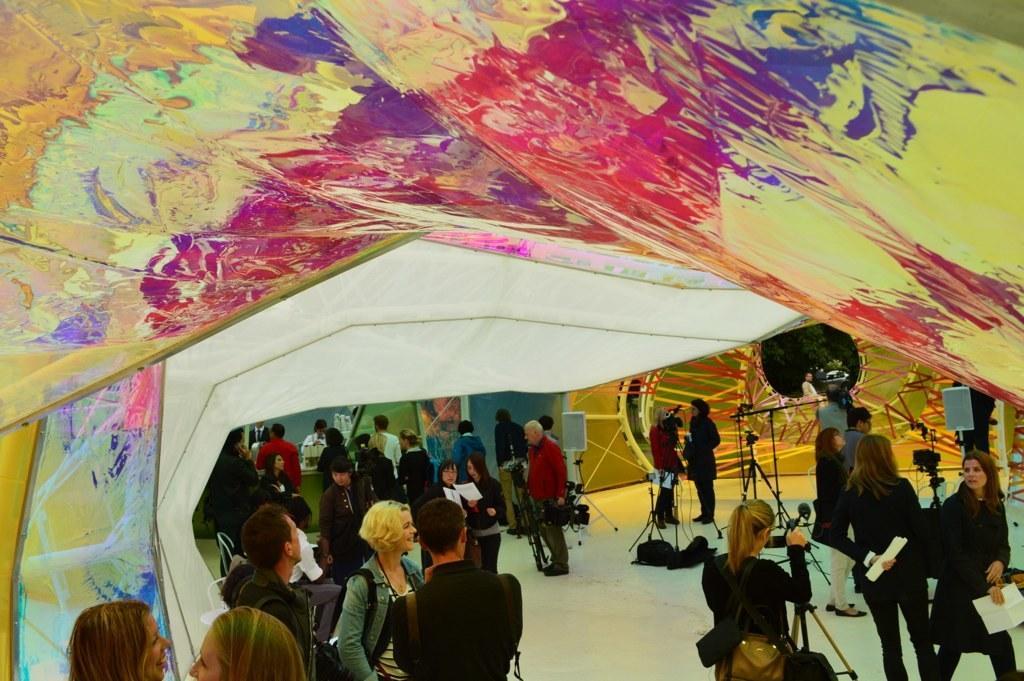In one or two sentences, can you explain what this image depicts? In this image, we can see people some are wearing bags and some are holding objects in their hands and we can see stands, boards and at the bottom, there is a floor and at the top, there is a tent. 